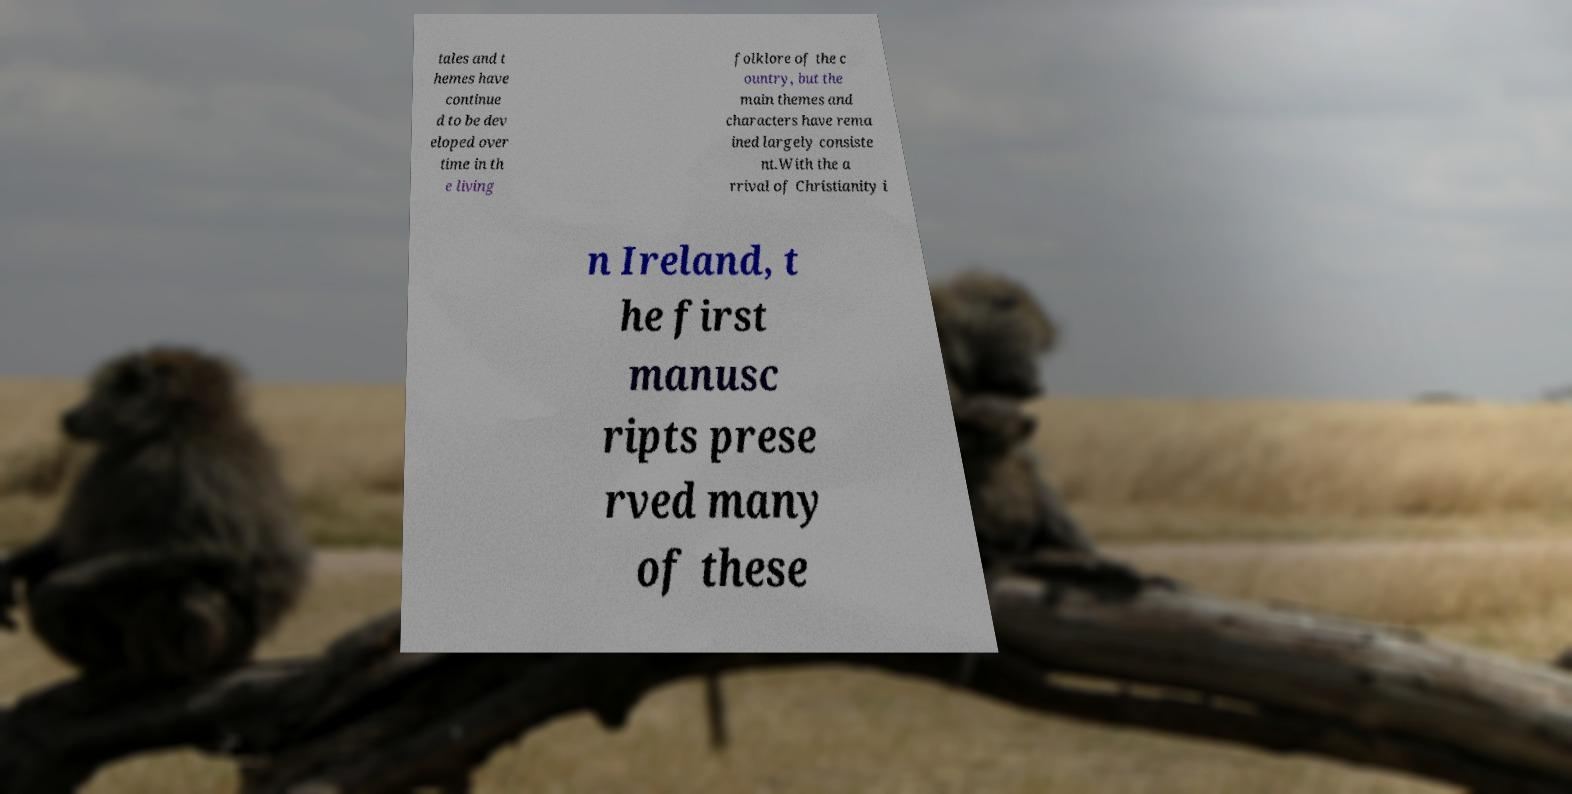Can you accurately transcribe the text from the provided image for me? tales and t hemes have continue d to be dev eloped over time in th e living folklore of the c ountry, but the main themes and characters have rema ined largely consiste nt.With the a rrival of Christianity i n Ireland, t he first manusc ripts prese rved many of these 